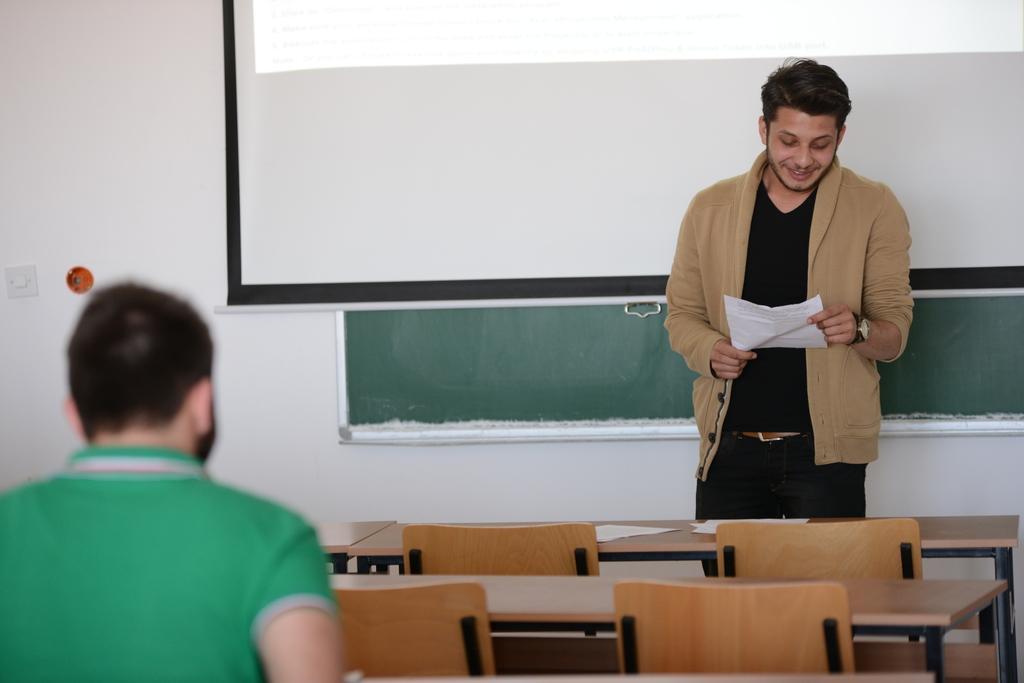In one or two sentences, can you explain what this image depicts? In this image, There are some table which are in yellow color and there are some chairs which are in brown color, In the left side of the image there is a boy sitting and in the right side of the image there is a boy standing and he is holding a white color paper, In the background there is a white color wall. 